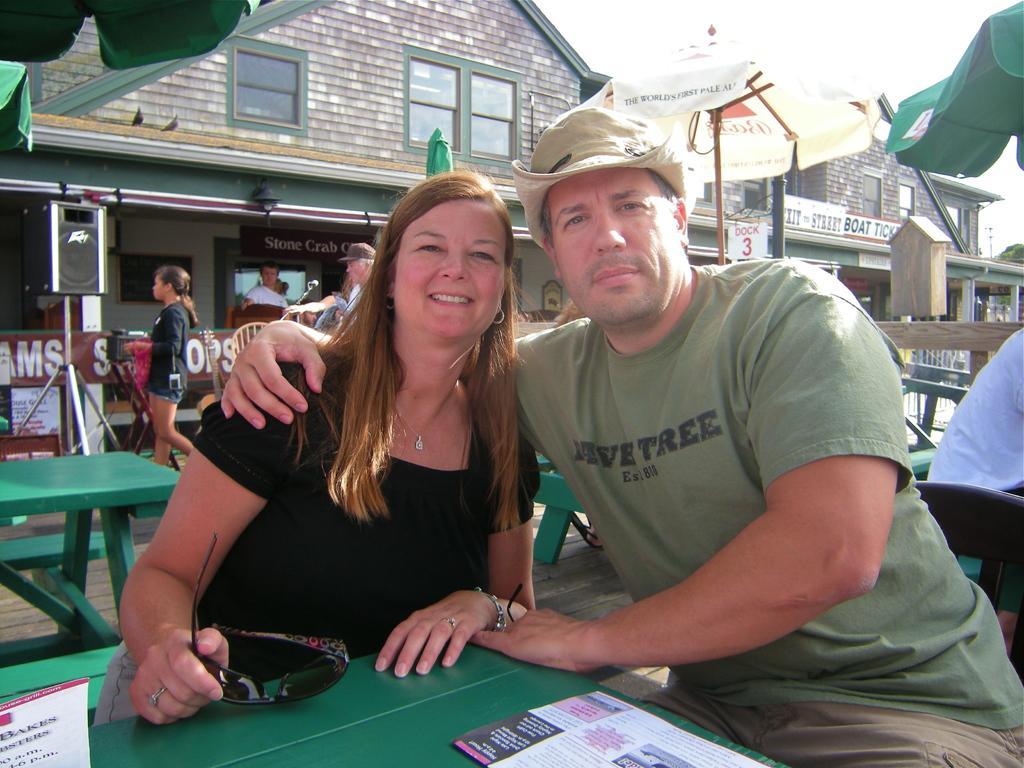How would you summarize this image in a sentence or two? In this image there are two person sitting on the bench. On the table there is a paper. At the back side we can see a building.. 